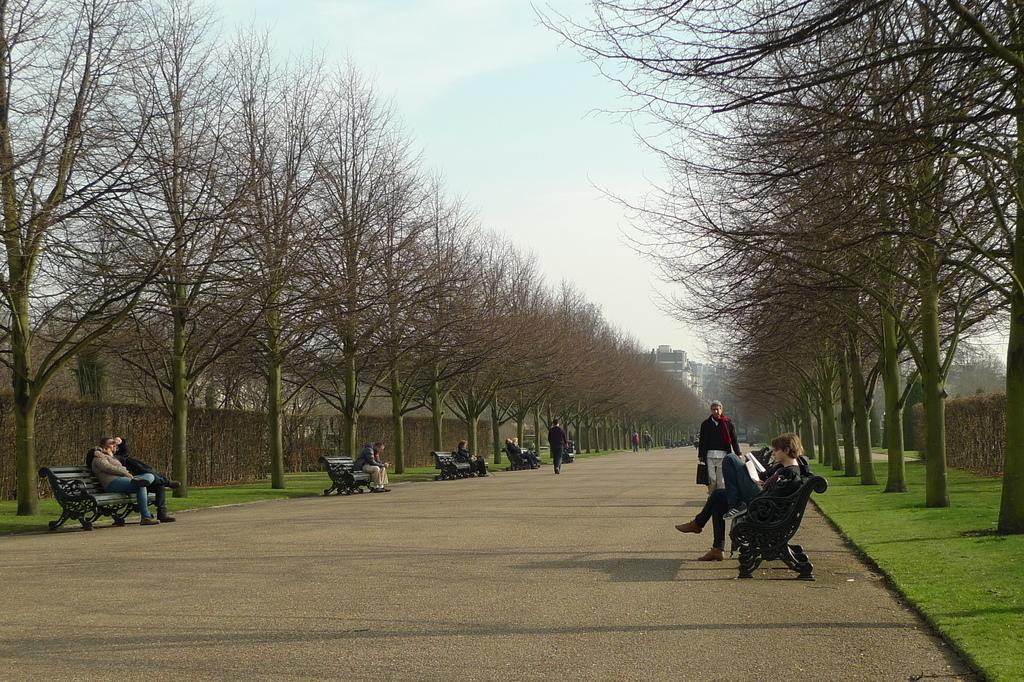What type of surface can be seen in the image? There is a road in the image. What objects are present for people to sit on? There are benches in the image. What are the people on the benches doing? People are sitting on the benches. What are some people doing in the image? Some people are walking. What type of vegetation is present in the image? There is grass in the image. What other natural elements can be seen in the image? There are trees in the image. What man-made structures are visible in the image? There are buildings in the image. What part of the natural environment is visible in the image? The sky is visible in the image. Can you see a fight happening between people in the image? There is no fight present in the image; people are sitting on benches or walking. What type of magic is being performed by the trees in the image? There is no magic being performed by the trees in the image; they are simply standing as part of the natural environment. 